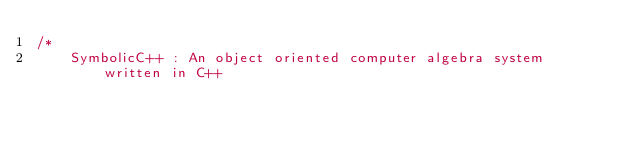Convert code to text. <code><loc_0><loc_0><loc_500><loc_500><_C++_>/*
    SymbolicC++ : An object oriented computer algebra system written in C++
</code> 